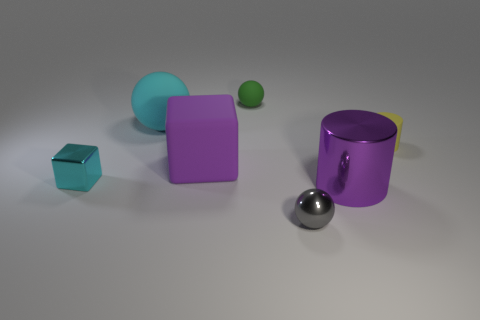Subtract all matte spheres. How many spheres are left? 1 Subtract all gray spheres. How many spheres are left? 2 Subtract all cylinders. How many objects are left? 5 Add 1 green matte things. How many objects exist? 8 Subtract 1 cubes. How many cubes are left? 1 Add 1 yellow cylinders. How many yellow cylinders are left? 2 Add 3 shiny cubes. How many shiny cubes exist? 4 Subtract 0 blue cylinders. How many objects are left? 7 Subtract all blue balls. Subtract all yellow cubes. How many balls are left? 3 Subtract all yellow spheres. How many yellow cylinders are left? 1 